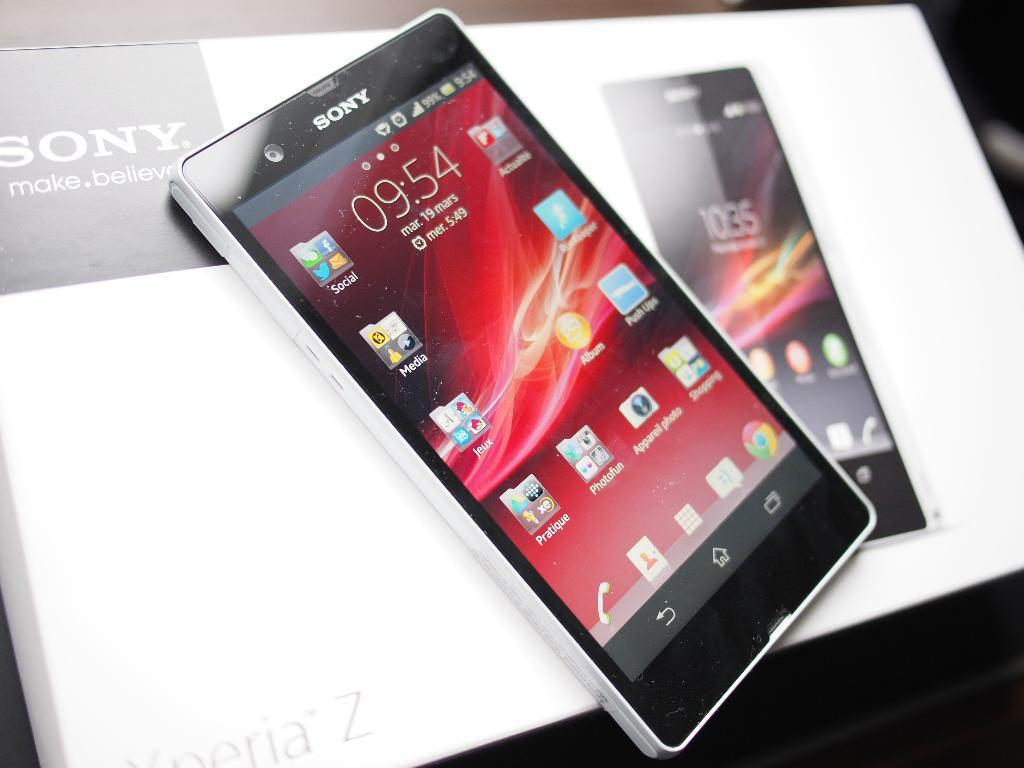Provide a one-sentence caption for the provided image. A Sony phone displays the home page with icons. 